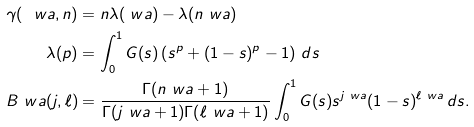Convert formula to latex. <formula><loc_0><loc_0><loc_500><loc_500>\gamma ( \ w a , n ) & = n \lambda ( \ w a ) - \lambda ( n \ w a ) \\ \lambda ( p ) & = \int _ { 0 } ^ { 1 } G ( s ) \left ( s ^ { p } + ( 1 - s ) ^ { p } - 1 \right ) \, d s \\ B _ { \ } w a ( j , \ell ) & = \frac { \Gamma ( n \ w a + 1 ) } { \Gamma ( j \ w a + 1 ) \Gamma ( \ell \ w a + 1 ) } \int _ { 0 } ^ { 1 } G ( s ) s ^ { j \ w a } ( 1 - s ) ^ { \ell \ w a } \, d s .</formula> 